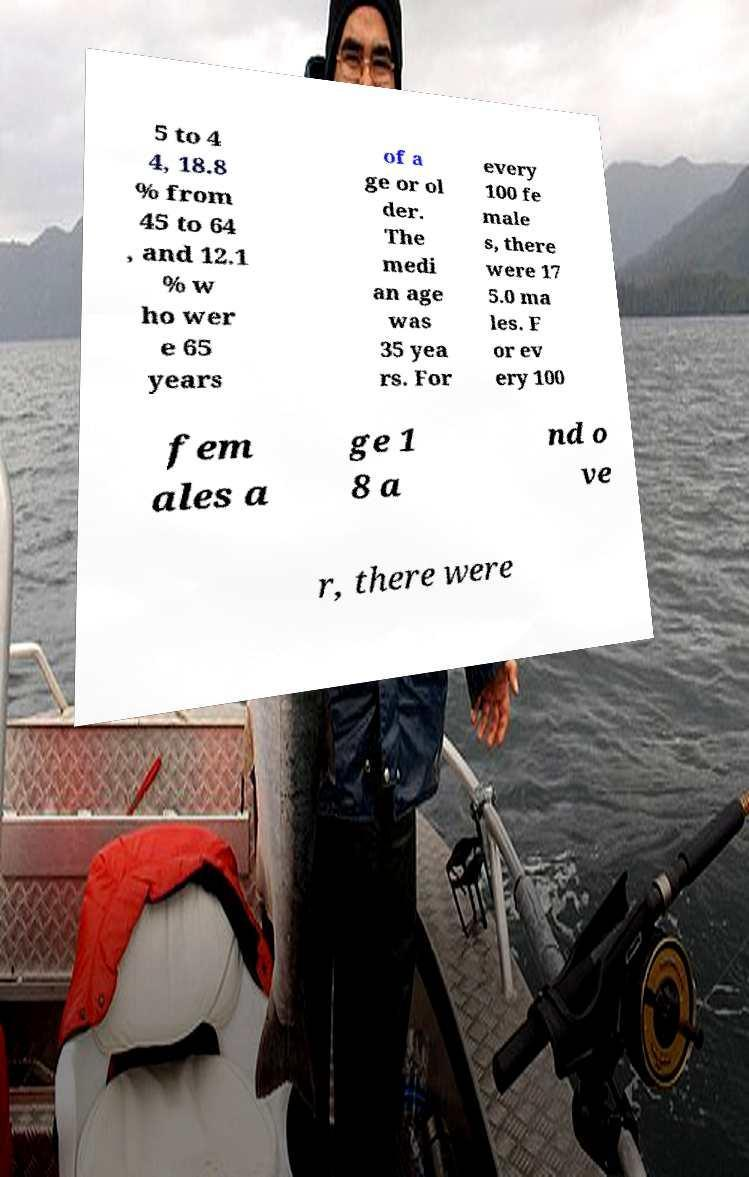Could you assist in decoding the text presented in this image and type it out clearly? 5 to 4 4, 18.8 % from 45 to 64 , and 12.1 % w ho wer e 65 years of a ge or ol der. The medi an age was 35 yea rs. For every 100 fe male s, there were 17 5.0 ma les. F or ev ery 100 fem ales a ge 1 8 a nd o ve r, there were 